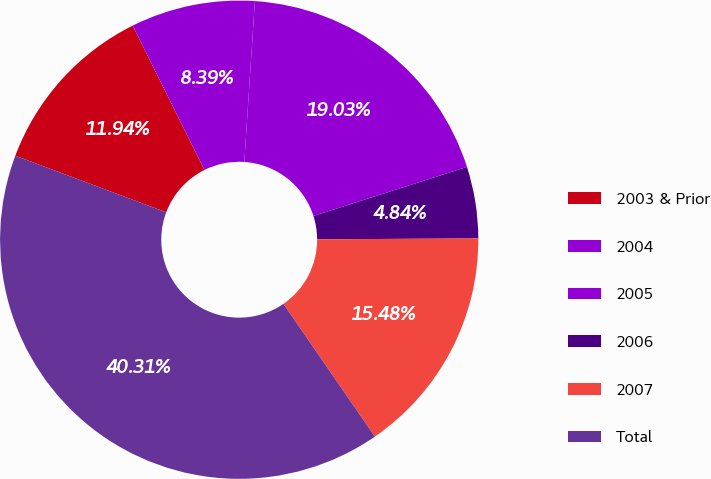Convert chart. <chart><loc_0><loc_0><loc_500><loc_500><pie_chart><fcel>2003 & Prior<fcel>2004<fcel>2005<fcel>2006<fcel>2007<fcel>Total<nl><fcel>11.94%<fcel>8.39%<fcel>19.03%<fcel>4.84%<fcel>15.48%<fcel>40.31%<nl></chart> 